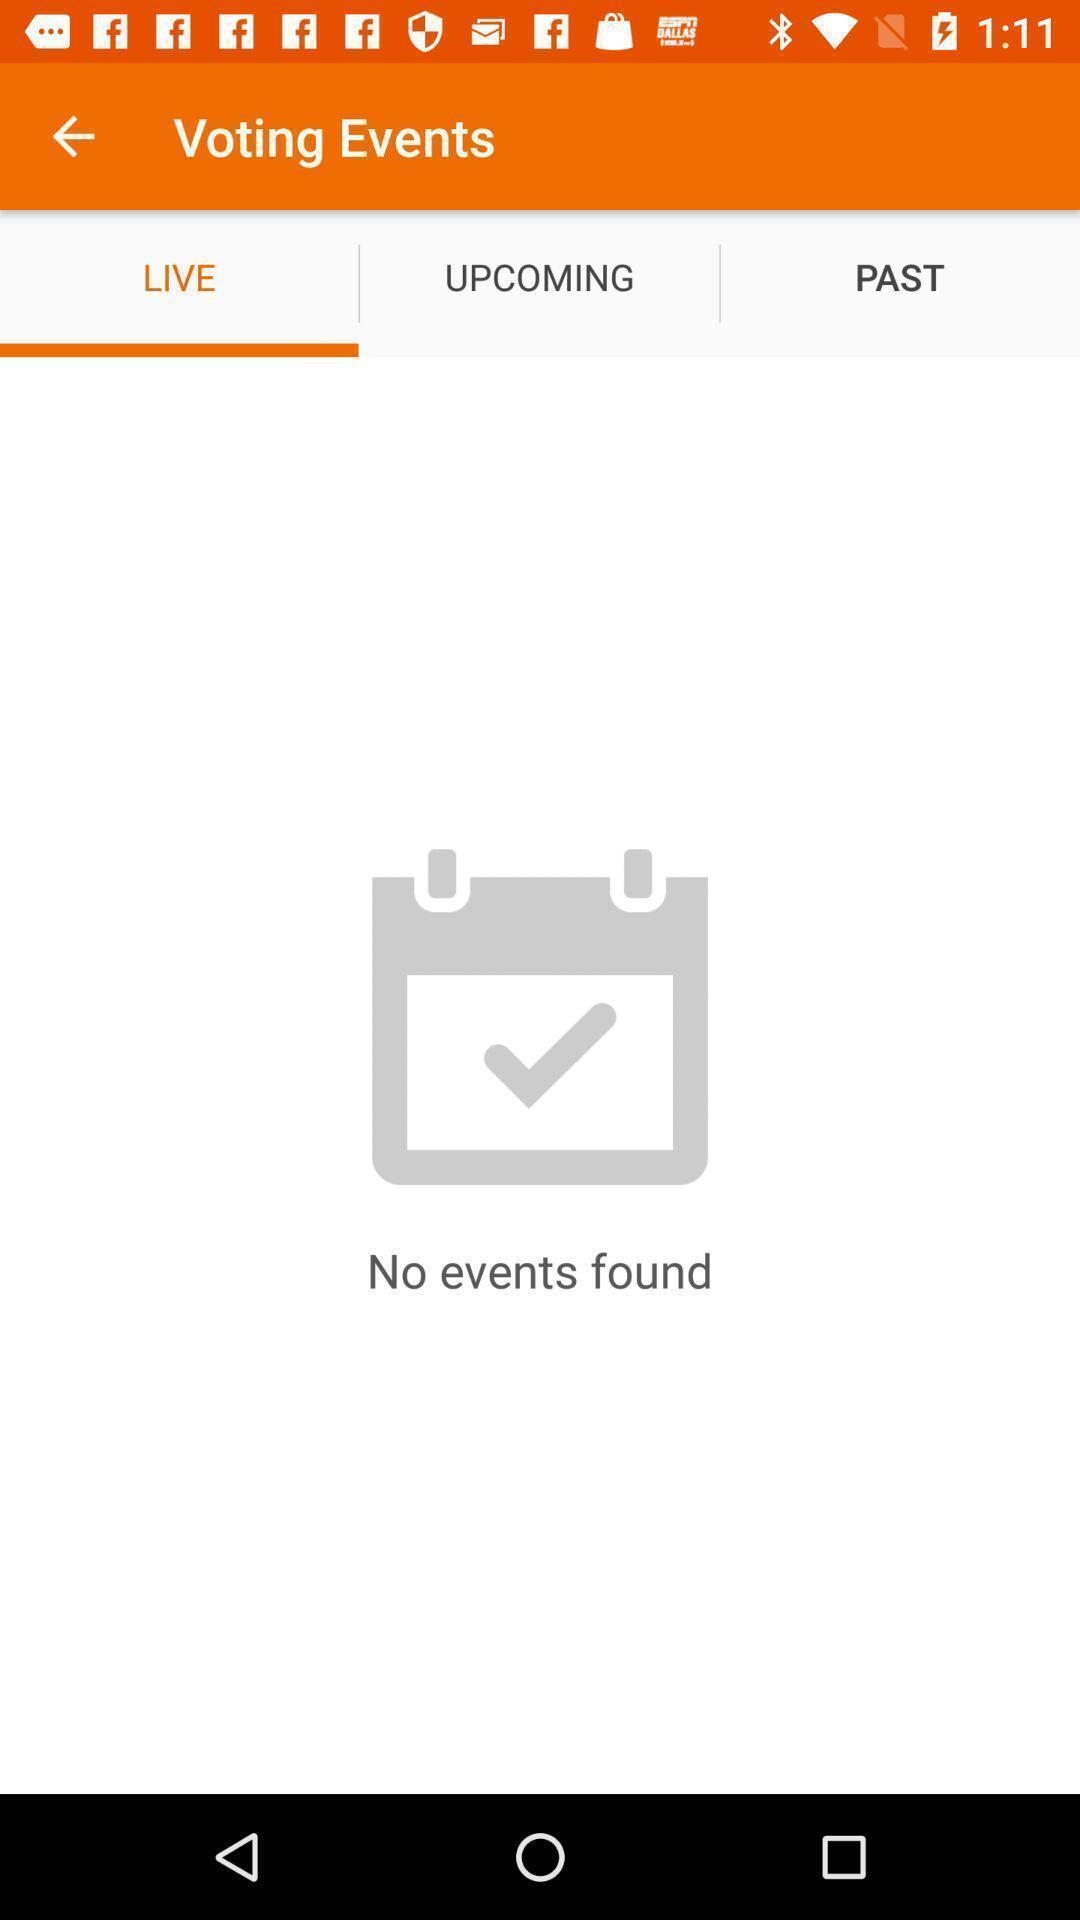What can you discern from this picture? Page displaying live voting events. 